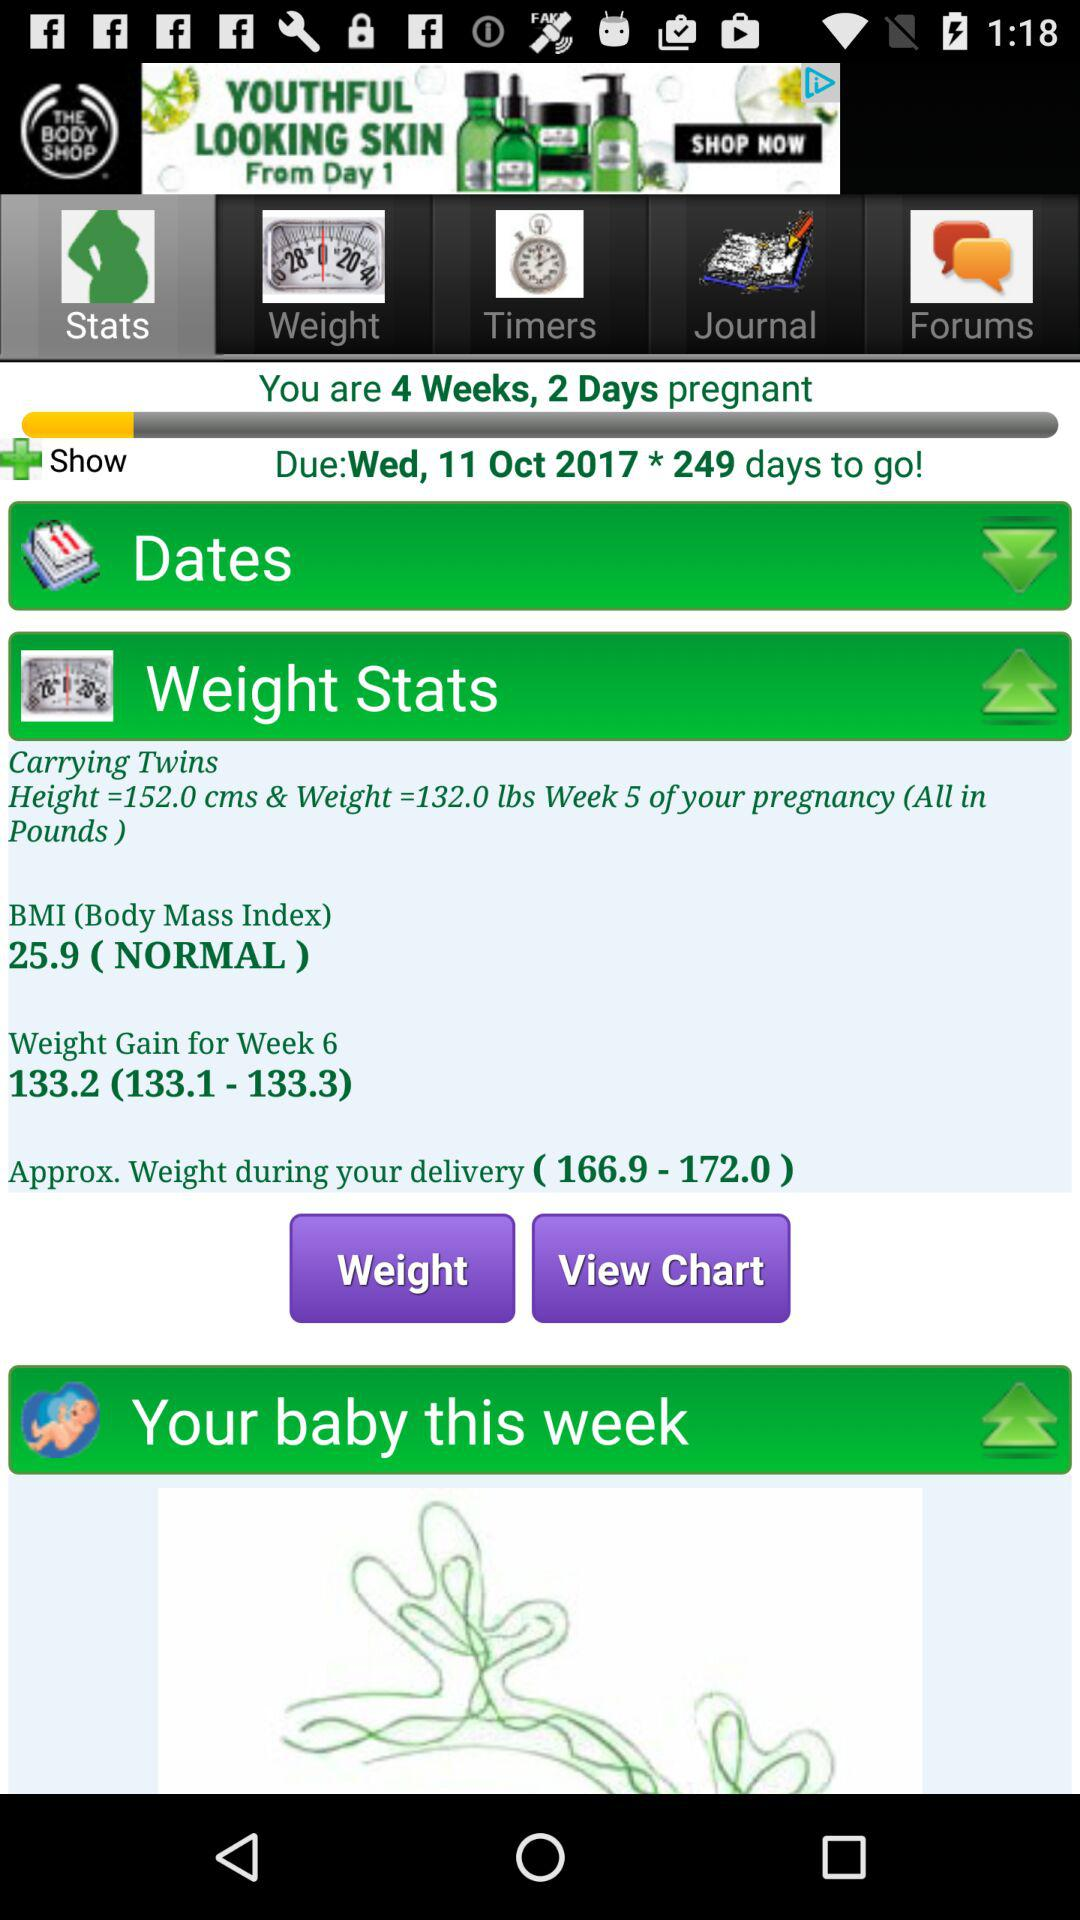What is the approx. weight during delivery? The approx. weight is between 166.9 and 172.0. 